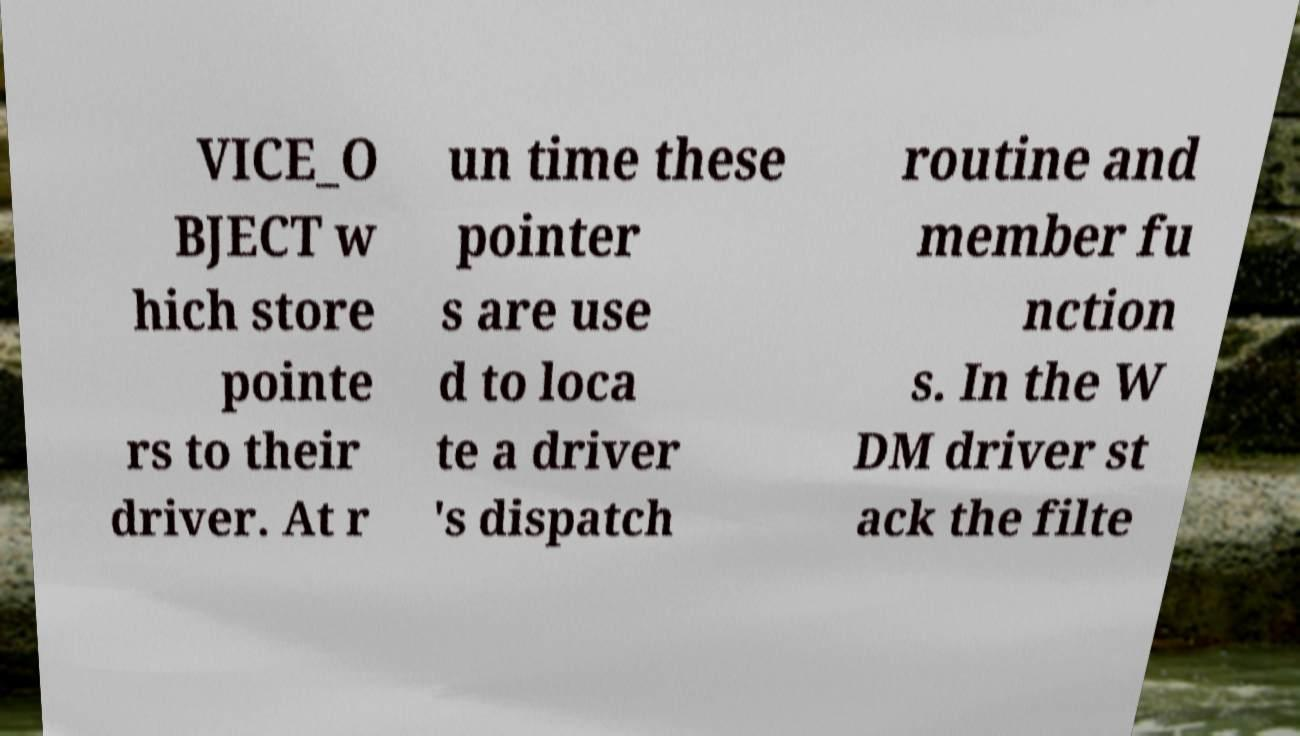Please read and relay the text visible in this image. What does it say? VICE_O BJECT w hich store pointe rs to their driver. At r un time these pointer s are use d to loca te a driver 's dispatch routine and member fu nction s. In the W DM driver st ack the filte 